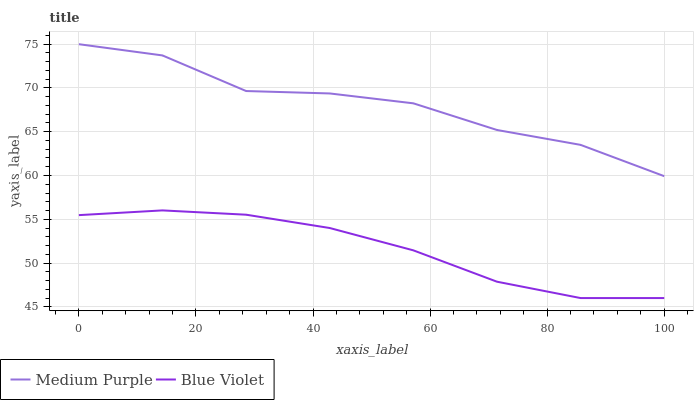Does Blue Violet have the minimum area under the curve?
Answer yes or no. Yes. Does Medium Purple have the maximum area under the curve?
Answer yes or no. Yes. Does Blue Violet have the maximum area under the curve?
Answer yes or no. No. Is Blue Violet the smoothest?
Answer yes or no. Yes. Is Medium Purple the roughest?
Answer yes or no. Yes. Is Blue Violet the roughest?
Answer yes or no. No. Does Blue Violet have the lowest value?
Answer yes or no. Yes. Does Medium Purple have the highest value?
Answer yes or no. Yes. Does Blue Violet have the highest value?
Answer yes or no. No. Is Blue Violet less than Medium Purple?
Answer yes or no. Yes. Is Medium Purple greater than Blue Violet?
Answer yes or no. Yes. Does Blue Violet intersect Medium Purple?
Answer yes or no. No. 